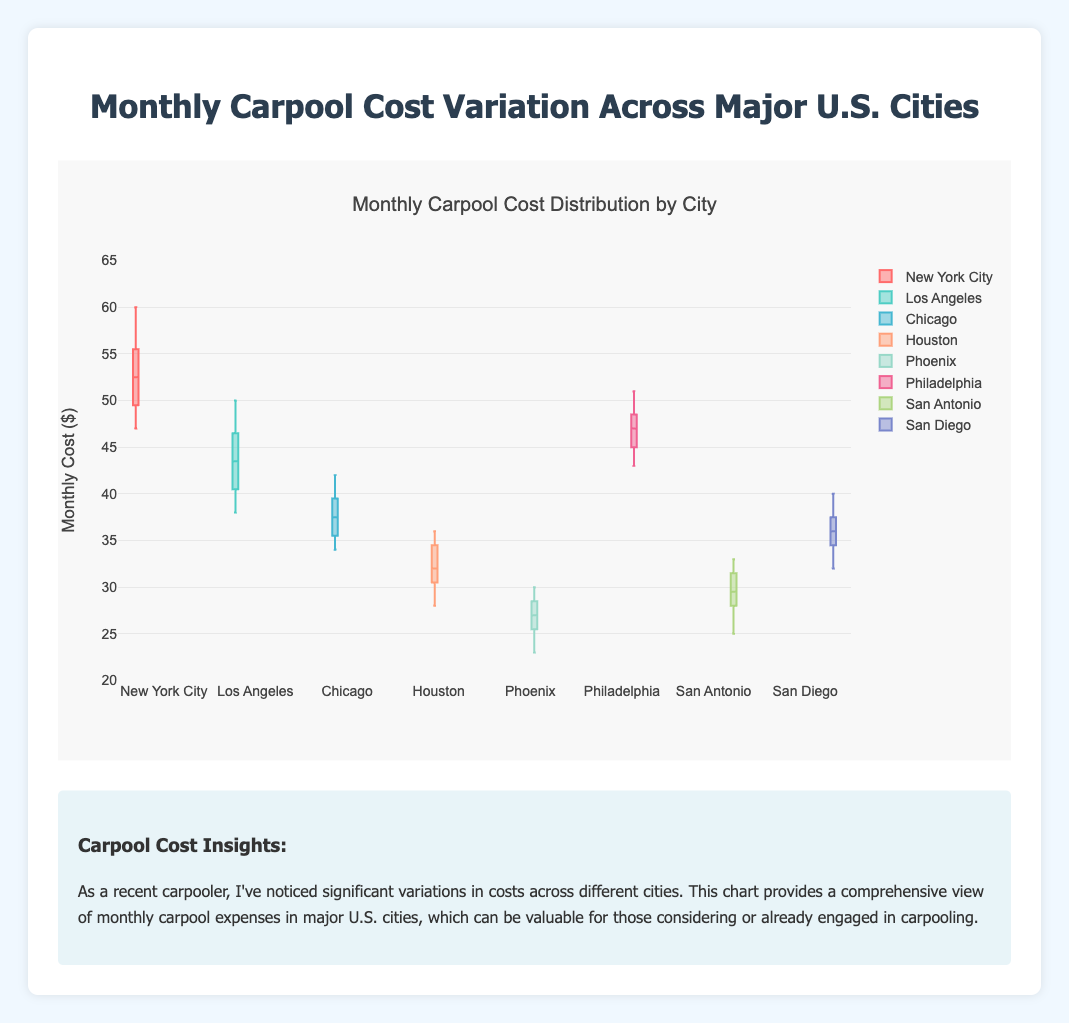What's the median carpool cost in New York City? To find the median, arrange New York City's carpool costs in order: [47, 48, 49, 50, 50, 52, 53, 54, 55, 56, 58, 60]. The median is the middle value, which, for an even number of data points, is the average of the two middle numbers (52 and 53)
Answer: 52.5 Which city has the highest median carpool cost? By observing the data, we can line up the median values of each city and identify that New York City has the highest median value.
Answer: New York City Which city has the smallest range of monthly carpool costs? The range is the difference between the maximum and minimum values in the data set. Calculate for each city and find that Houston has the smallest range because 36 - 28 = 8.
Answer: Houston Which city's carpool cost data has the largest interquartile range (IQR)? IQR is the difference between the third quartile (Q3) and the first quartile (Q1). Compare the IQRs by observing the box plots and find that New York City has the largest IQR since it spans a wider region on the chart.
Answer: New York City Compare the median carpool costs between Phoenix and San Antonio. What do you notice? By looking at the box plots, Phoenix has a median near the higher end of its range, while San Antonio has a slightly higher median than Phoenix.
Answer: San Antonio's median is slightly higher than Phoenix's What is a suspected outlier in Los Angeles carpool costs? Observing the box plot for Los Angeles, the data point 38 is marked as a suspected outlier since it falls far below the lower quartile range.
Answer: 38 Which city has the lowest minimum carpool cost? Compare the minimum data points (the lower whiskers) of all the cities, and find that Phoenix has the lowest minimum cost at 23.
Answer: Phoenix Compare the range of monthly costs in New York City and San Diego. Which city has a larger range? Calculate the range by subtracting the minimum from the maximum for both cities. New York City's range is 60 - 47 = 13, and San Diego's range is 40 - 32 = 8. New York City has a larger range.
Answer: New York City Which city has the widest box in the box plot (indicating the spread within the interquartile range)? Inspect the box plots and see that New York City has the widest box, indicating a larger spread within the interquartile range.
Answer: New York City 